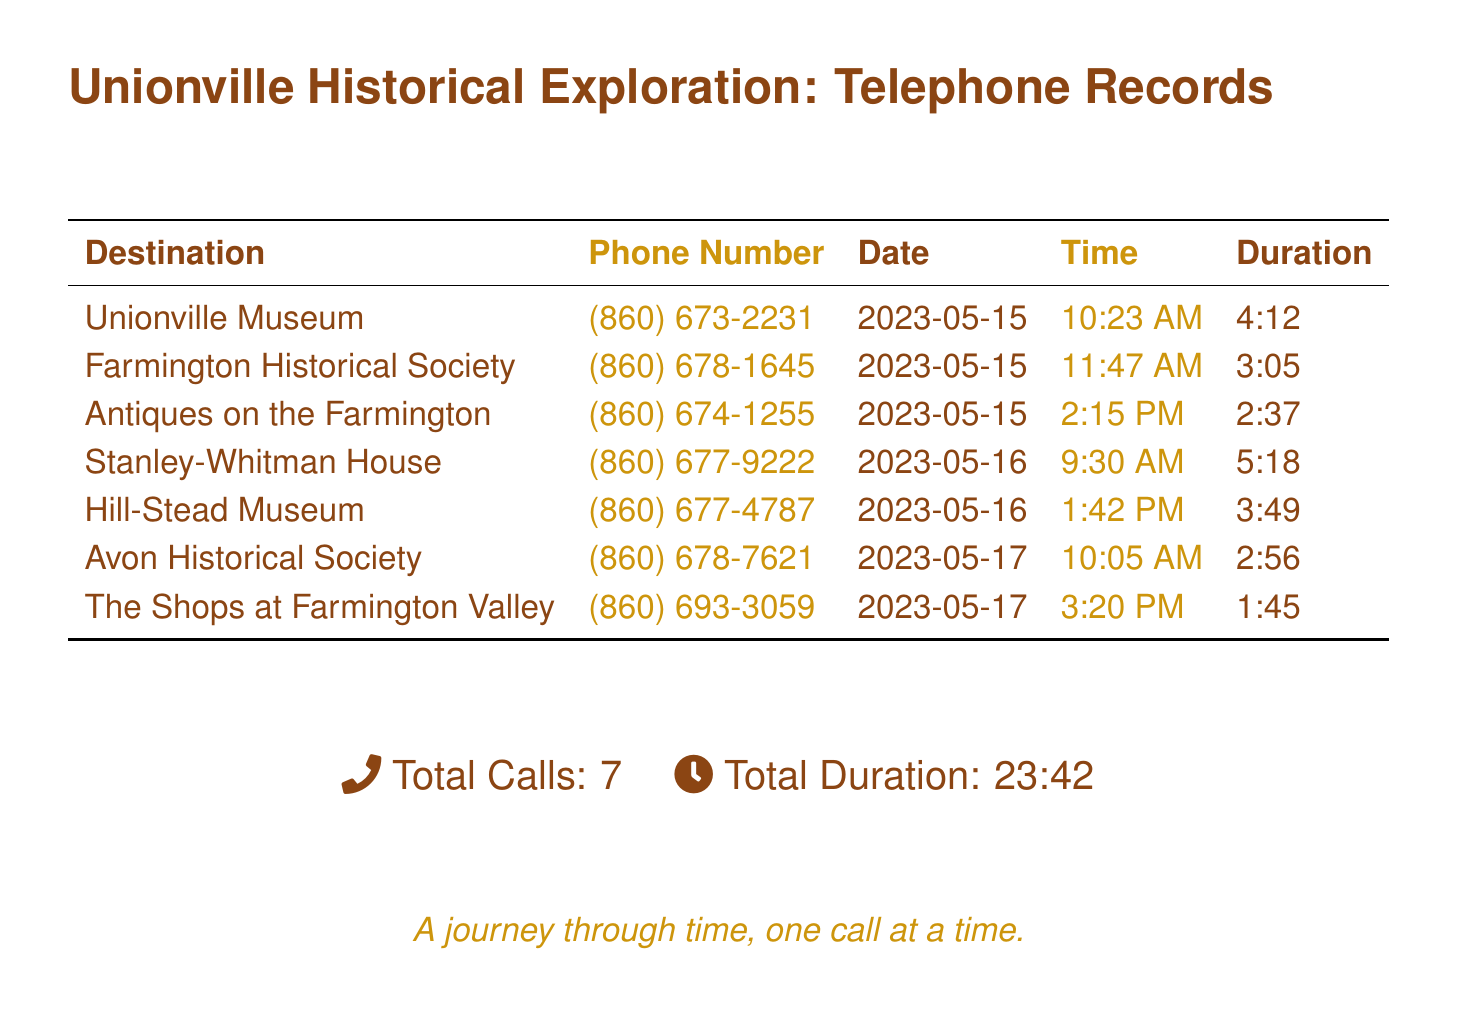what is the phone number for Unionville Museum? The phone number for Unionville Museum is listed in the document under the relevant destination.
Answer: (860) 673-2231 how many calls were made on May 16? The document lists the calls along with their corresponding dates, allowing us to count how many were made on May 16.
Answer: 2 what was the duration of the call to Antiques on the Farmington? The document specifies the duration of each call made to different antique shops and museums in the area.
Answer: 2:37 which location had the longest call duration? By comparing the durations provided for each call, we can determine which had the longest call duration.
Answer: Stanley-Whitman House total duration of all calls? The document states the total duration of all calls at the bottom, summarizing the information provided.
Answer: 23:42 how many total unique locations are called in the records? The document lists each unique destination, enabling a count of the total unique locations called.
Answer: 7 what time was the call made to Hill-Stead Museum? The document includes a specific time for each call, allowing us to identify the time for the call to Hill-Stead Museum.
Answer: 1:42 PM 